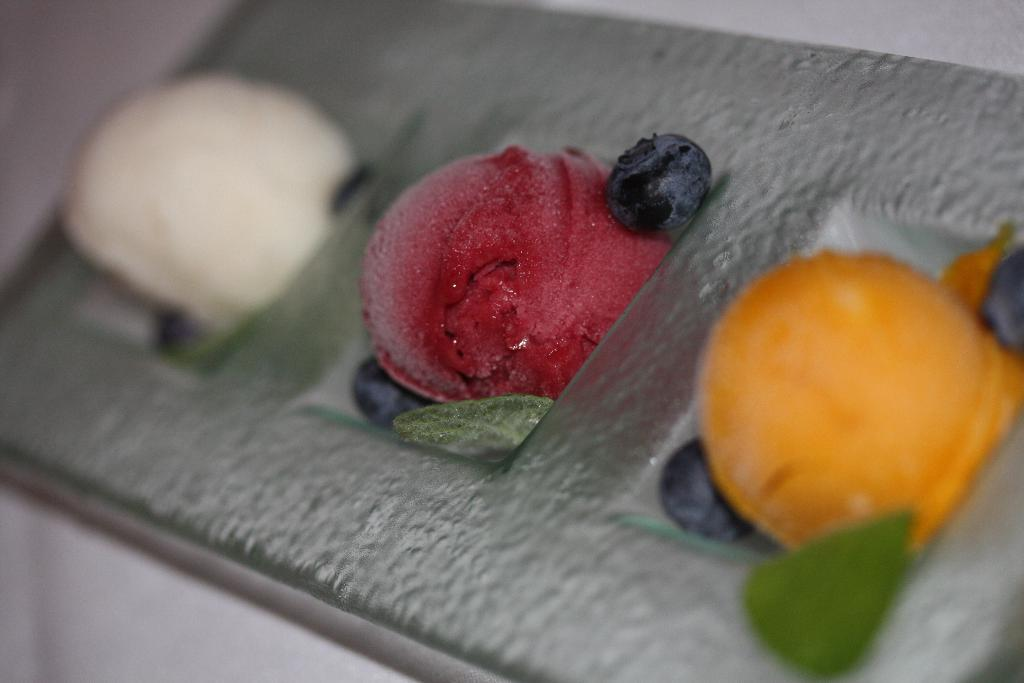What types of plants are visible in the image? There are flowers in the image. What else is present on the same surface as the flowers? There are fruits in the image. Can you describe the location or surface where the flowers and fruits are placed? The flowers and fruits are present on a place or surface. What type of animal can be seen interacting with the flowers in the image? There is no animal present in the image; it only features flowers and fruits. What kind of weather can be observed in the image? The image does not provide any information about the weather, as it only shows flowers and fruits on a surface. 